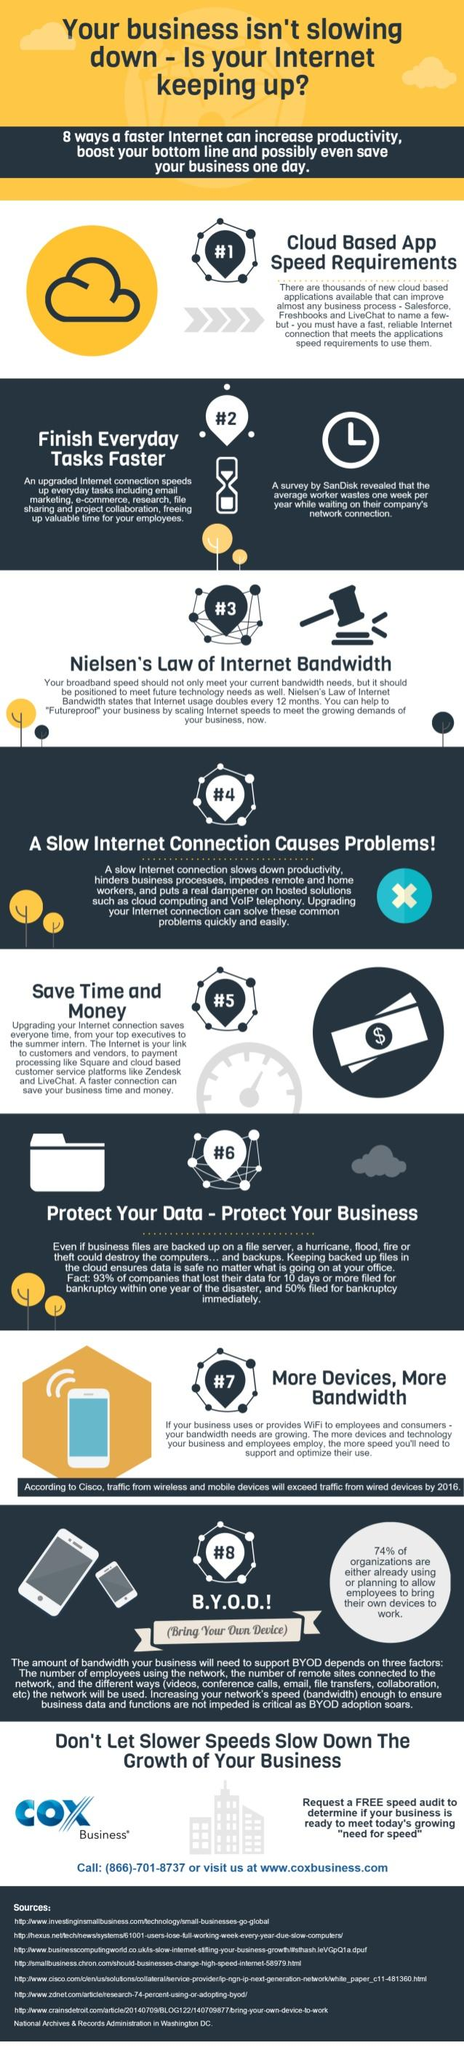Mention a couple of crucial points in this snapshot. The third method to increase internet bandwidth is Nielsen's Law of Internet Bandwidth, which states that the amount of internet bandwidth required for a given network doubles approximately every 18-24 months. 